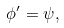<formula> <loc_0><loc_0><loc_500><loc_500>\phi ^ { \prime } = \psi ,</formula> 